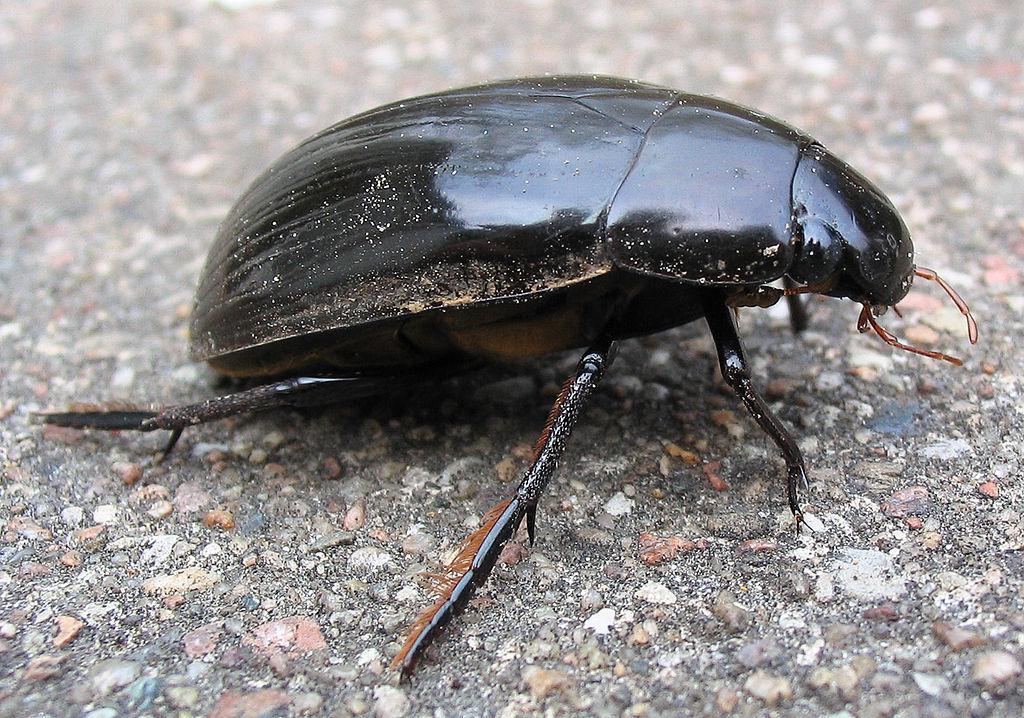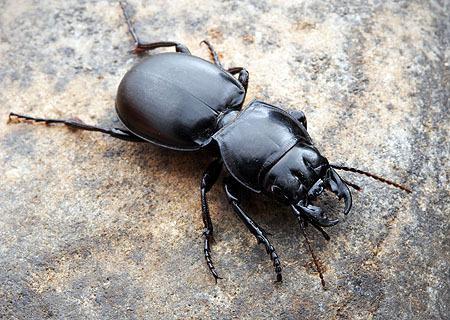The first image is the image on the left, the second image is the image on the right. Analyze the images presented: Is the assertion "There is no ball in the image on the left" valid? Answer yes or no. Yes. The first image is the image on the left, the second image is the image on the right. Evaluate the accuracy of this statement regarding the images: "There is a bug in each image on a ball of sediment.". Is it true? Answer yes or no. No. The first image is the image on the left, the second image is the image on the right. Considering the images on both sides, is "At least one beatle has its hind legs on a ball while its front legs are on the ground." valid? Answer yes or no. No. 